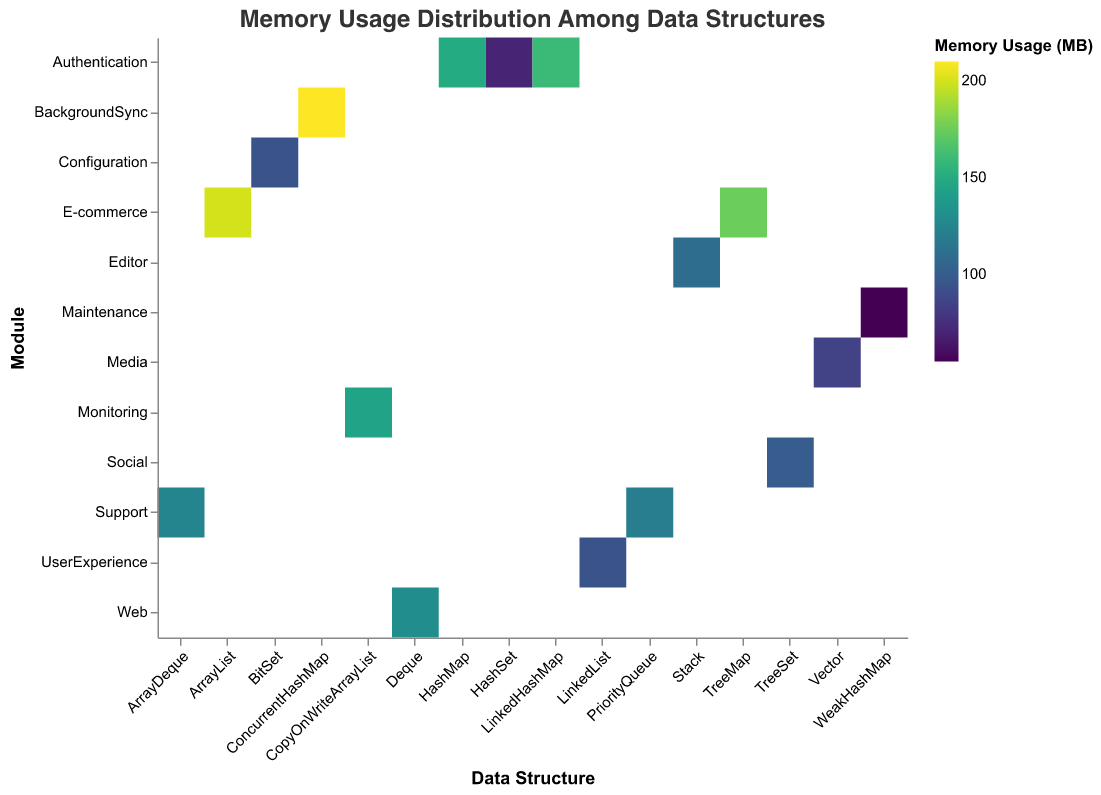What is the title of the heatmap? The title is displayed at the top of the heatmap, reading "Memory Usage Distribution Among Data Structures".
Answer: Memory Usage Distribution Among Data Structures Which data structure has the highest memory usage? By observing the color scale and the blocks of the heatmap, the data structure with the highest memory usage, indicated by the darkest color, is ConcurrentHashMap. The tooltip shows it has 210 MB.
Answer: ConcurrentHashMap What module uses the HashMap data structure, and how much memory does it consume? We locate the HashMap in the x-axis and see the corresponding y-axis module. According to the tooltip info, the module is Authentication, and the memory usage is 150 MB.
Answer: Authentication, 150 MB Which module has the overall highest memory usage, and which data structure contributes the most to it? By comparing the blocks on the heatmap and their colors, the E-commerce module has the highest memory usage, summing ArrayList (200 MB) and TreeMap (175 MB) for a total of 375 MB. ArrayList has the highest individual contribution of 200 MB.
Answer: E-commerce, ArrayList Compare the memory usages of HashSet and CopyOnWriteArrayList. Which has higher memory consumption? The heatmap shows HashSet in light color (70 MB) and CopyOnWriteArrayList in a darker color (145 MB). By comparing the values, CopyOnWriteArrayList consumes more memory.
Answer: CopyOnWriteArrayList How many data structures are used in the Authentication module, and what is the combined memory usage? By checking the heatmap, we find and count HashMap (150 MB), HashSet (70 MB), and LinkedHashMap (160 MB) under the Authentication module. The combined memory usage sums up to 380 MB.
Answer: 3, 380 MB Which data structure is used in the Configuration module, and what is its memory usage? By locating the Configuration module on the y-axis, BitSet is identified as the data structure shown in the tooltip, consuming 95 MB of memory.
Answer: BitSet, 95 MB Which data structure in the Support module has the highest memory usage? Navigating to the Support module on the heatmap, we find two data structures: PriorityQueue with 120 MB and ArrayDeque with 125 MB. ArrayDeque has the highest memory usage.
Answer: ArrayDeque What is the range of memory usage among the data structures in the heatmap? By examining the tooltip across all data structures, the minimum memory usage is by WeakHashMap (55 MB) and the maximum by ConcurrentHashMap (210 MB). The range is the difference between these values.
Answer: 155 MB 